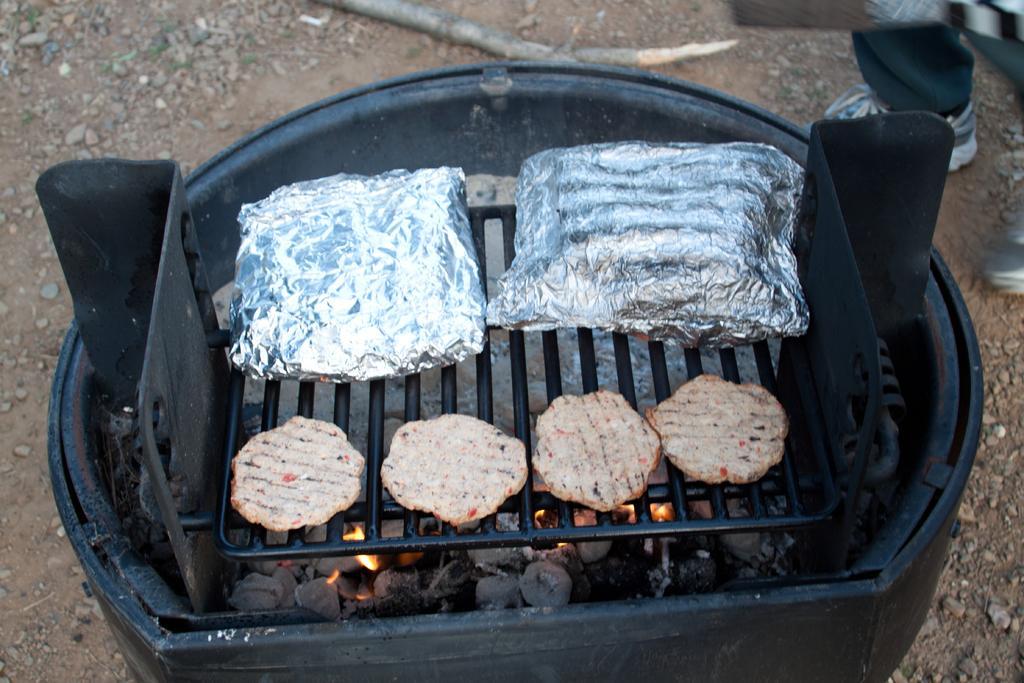Describe this image in one or two sentences. In this image we can see some food items and silver foils which are kept on grill and we can see coals which are fired are in the black color thing. 